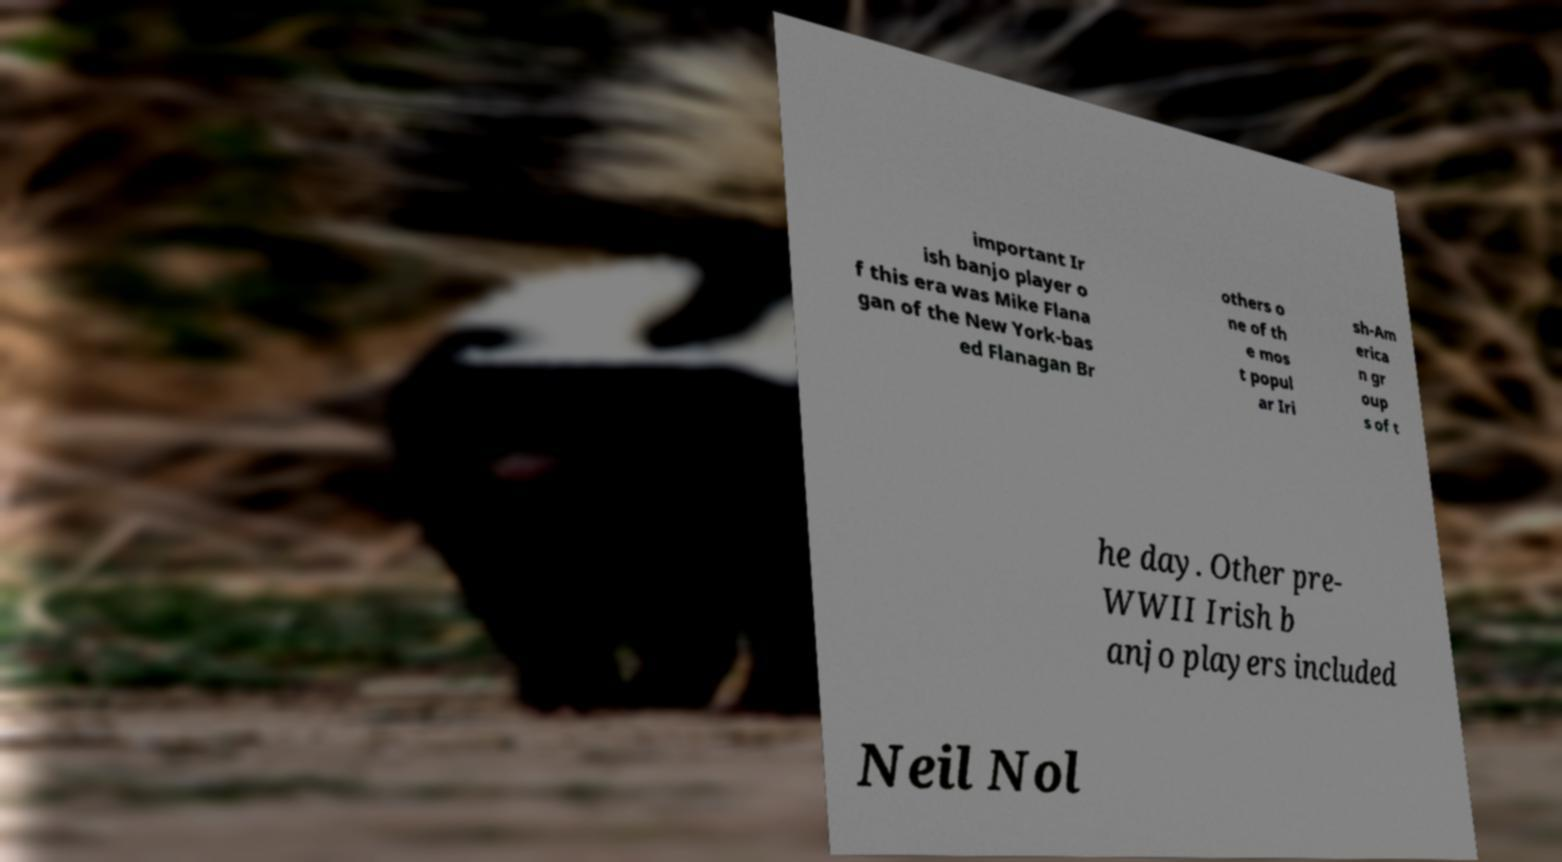Could you assist in decoding the text presented in this image and type it out clearly? important Ir ish banjo player o f this era was Mike Flana gan of the New York-bas ed Flanagan Br others o ne of th e mos t popul ar Iri sh-Am erica n gr oup s of t he day. Other pre- WWII Irish b anjo players included Neil Nol 